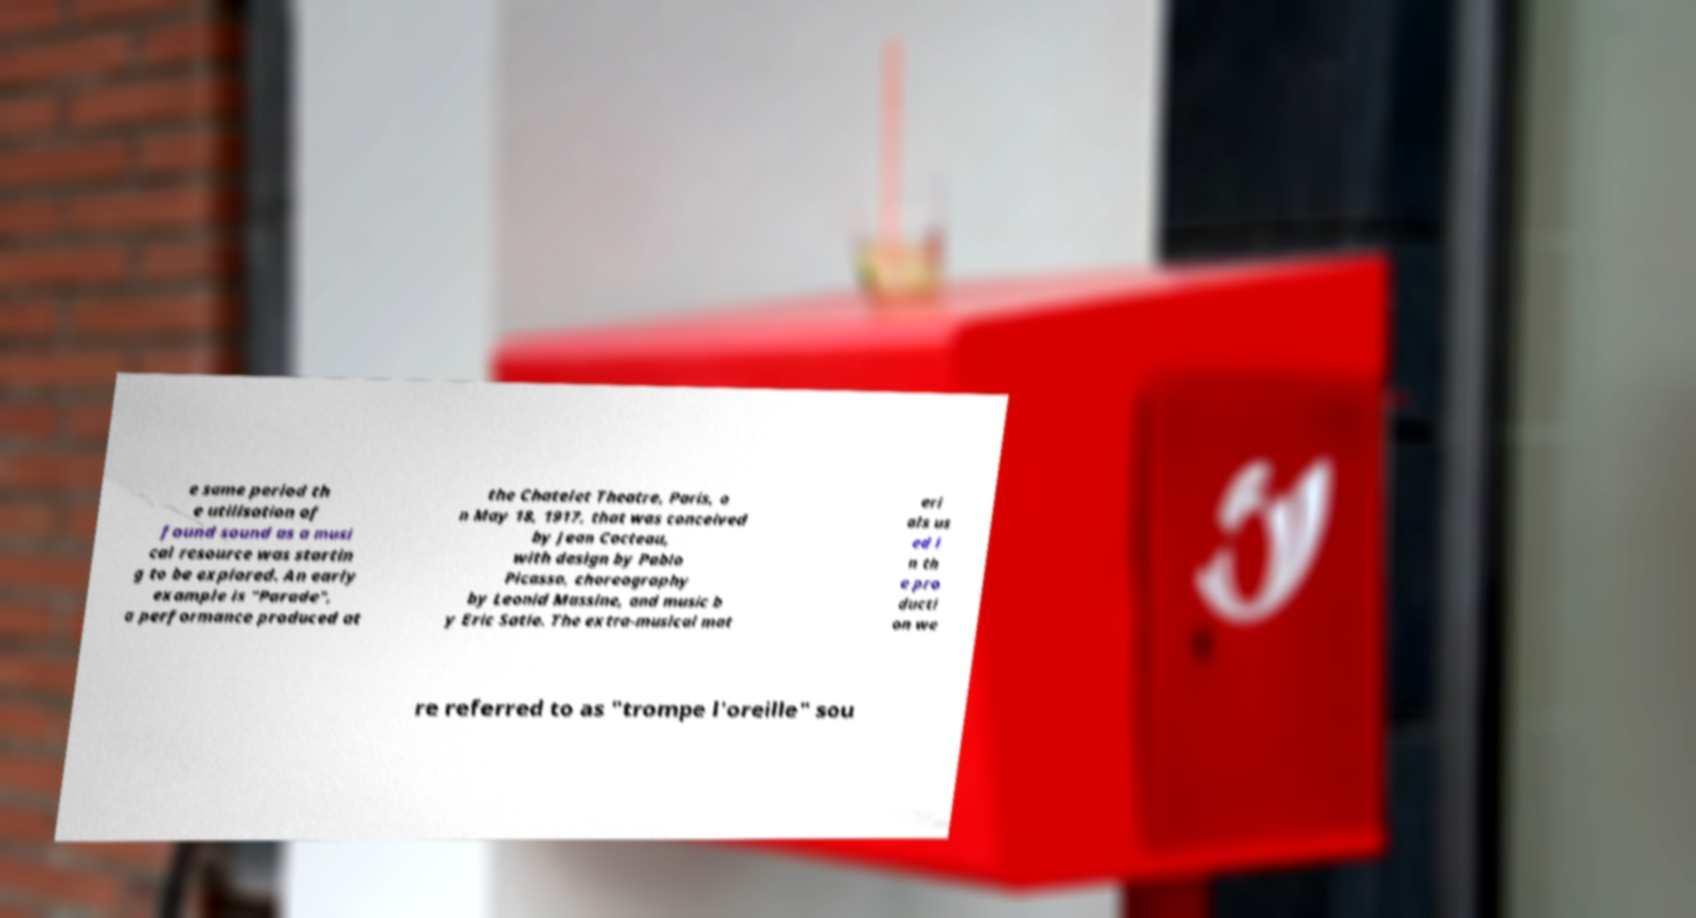Can you read and provide the text displayed in the image?This photo seems to have some interesting text. Can you extract and type it out for me? e same period th e utilisation of found sound as a musi cal resource was startin g to be explored. An early example is "Parade", a performance produced at the Chatelet Theatre, Paris, o n May 18, 1917, that was conceived by Jean Cocteau, with design by Pablo Picasso, choreography by Leonid Massine, and music b y Eric Satie. The extra-musical mat eri als us ed i n th e pro ducti on we re referred to as "trompe l'oreille" sou 